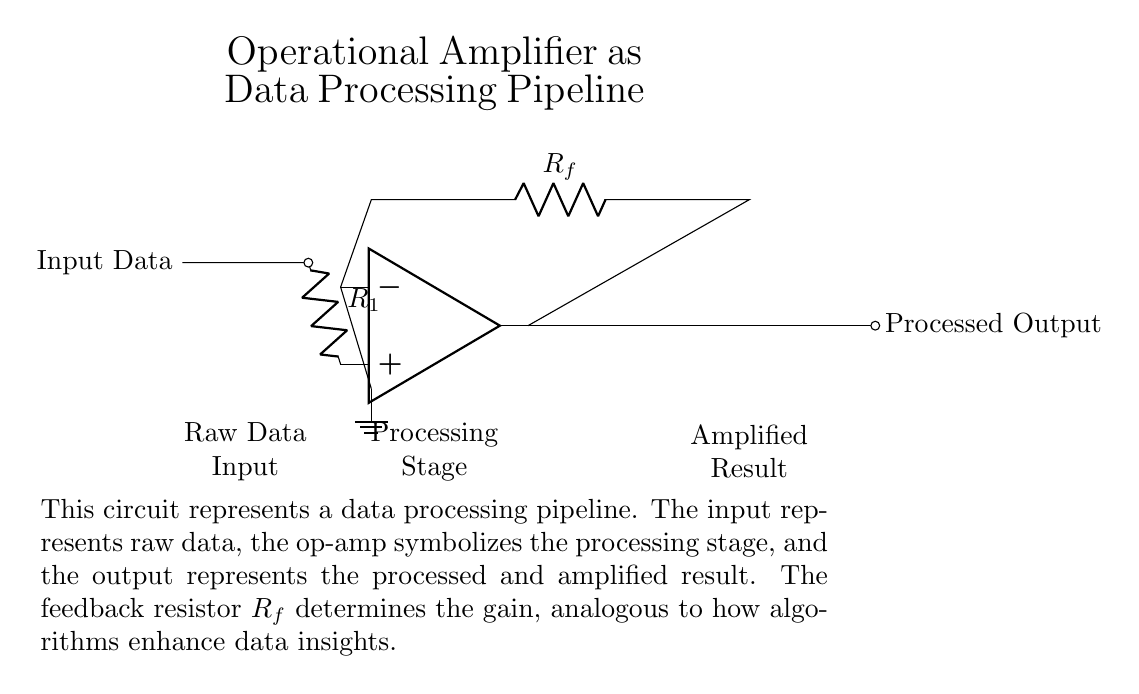What is the type of circuit depicted? The circuit is an operational amplifier circuit, commonly used for amplifying signals in various applications. The use of the icon representing an operational amplifier confirms this.
Answer: operational amplifier What does the feedback resistor Rf do? The feedback resistor Rf controls the gain of the operational amplifier, which determines how much the input signal is amplified. The gain is calculated based on the values of R1 and Rf.
Answer: controls gain Where is the raw data input in the circuit? The raw data input is located on the left side of the circuit diagram, entering the operational amplifier at the non-inverting input.
Answer: left side What is represented by the output node of the op-amp? The output node of the operational amplifier represents the processed and amplified result of the input data, which is depicted on the right side of the circuit.
Answer: processed output How does increasing the resistance Rf affect the output? Increasing the resistance Rf will increase the gain of the operational amplifier, resulting in a larger amplified output signal for the same input data. This is because the gain is proportional to the ratio of Rf and R1.
Answer: increases output What does the ground symbol indicate in this circuit? The ground symbol indicates a reference point in the circuit, providing a common return path for electrical current, and it establishes a zero-voltage reference for the op-amp's negative input.
Answer: reference point Which node indicates the processing stage in the circuit? The processing stage is represented by the operational amplifier itself, as this is where the input data is processed and amplified before being sent to the output node.
Answer: operational amplifier 